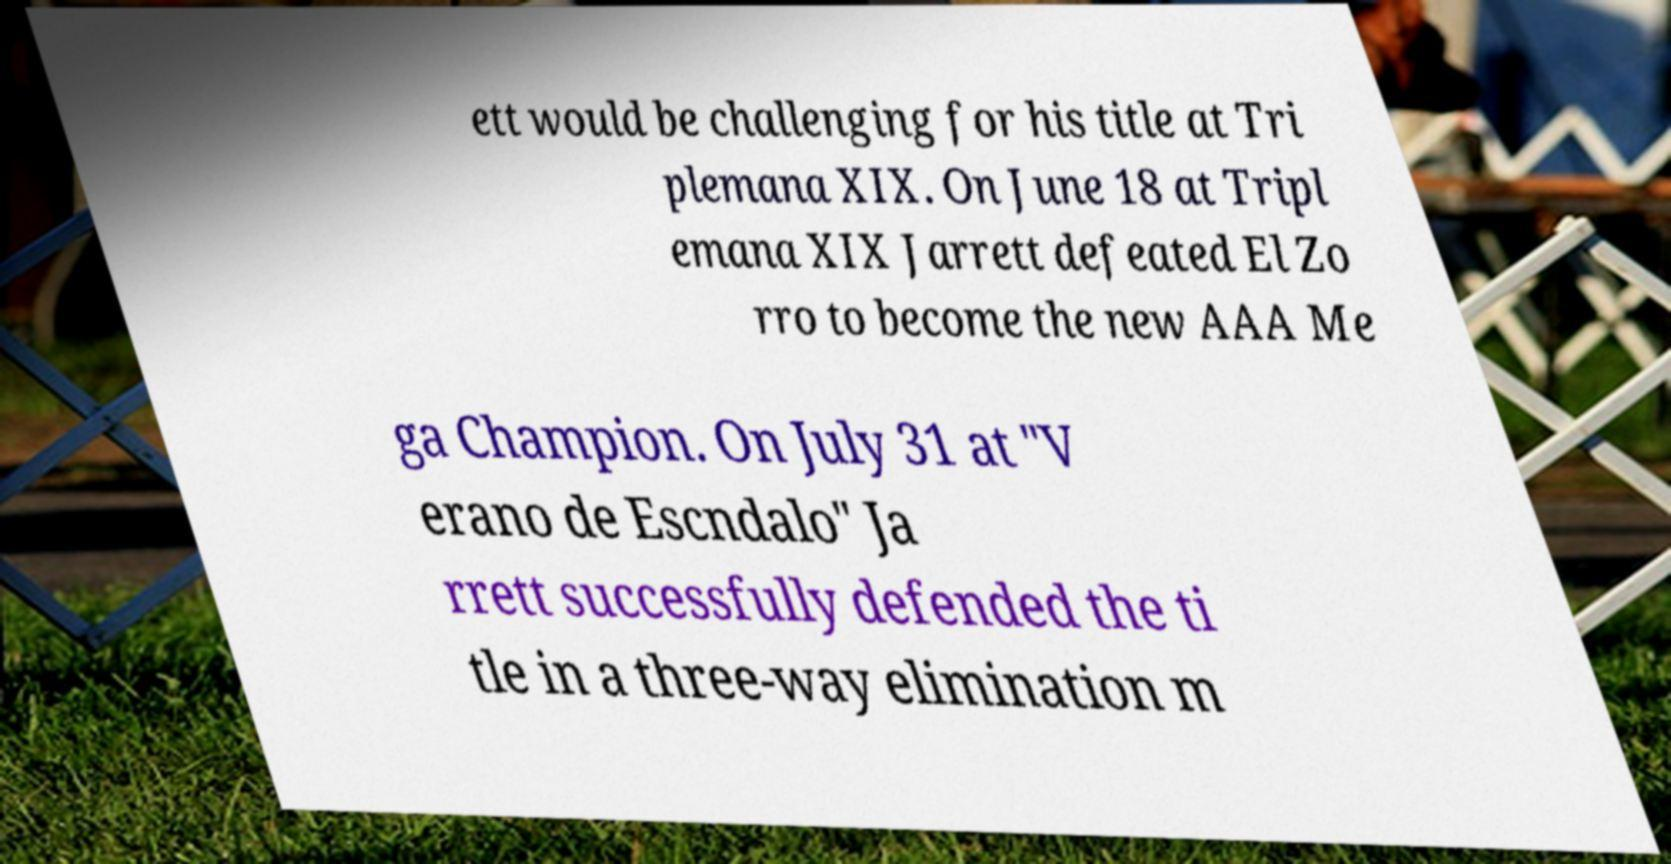Could you assist in decoding the text presented in this image and type it out clearly? ett would be challenging for his title at Tri plemana XIX. On June 18 at Tripl emana XIX Jarrett defeated El Zo rro to become the new AAA Me ga Champion. On July 31 at "V erano de Escndalo" Ja rrett successfully defended the ti tle in a three-way elimination m 